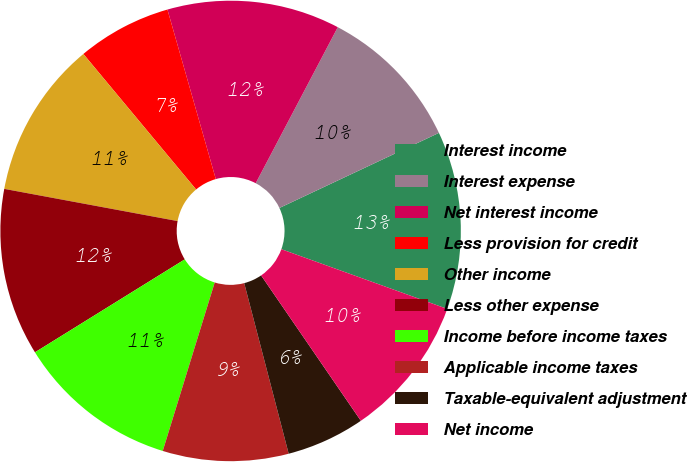Convert chart to OTSL. <chart><loc_0><loc_0><loc_500><loc_500><pie_chart><fcel>Interest income<fcel>Interest expense<fcel>Net interest income<fcel>Less provision for credit<fcel>Other income<fcel>Less other expense<fcel>Income before income taxes<fcel>Applicable income taxes<fcel>Taxable-equivalent adjustment<fcel>Net income<nl><fcel>12.5%<fcel>10.29%<fcel>12.13%<fcel>6.62%<fcel>11.03%<fcel>11.76%<fcel>11.4%<fcel>8.82%<fcel>5.51%<fcel>9.93%<nl></chart> 